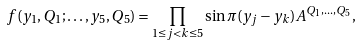Convert formula to latex. <formula><loc_0><loc_0><loc_500><loc_500>f ( y _ { 1 } , Q _ { 1 } ; \dots , y _ { 5 } , Q _ { 5 } ) = \prod _ { 1 \leq j < k \leq 5 } \sin \pi ( y _ { j } - y _ { k } ) A ^ { Q _ { 1 } , \dots , Q _ { 5 } } ,</formula> 